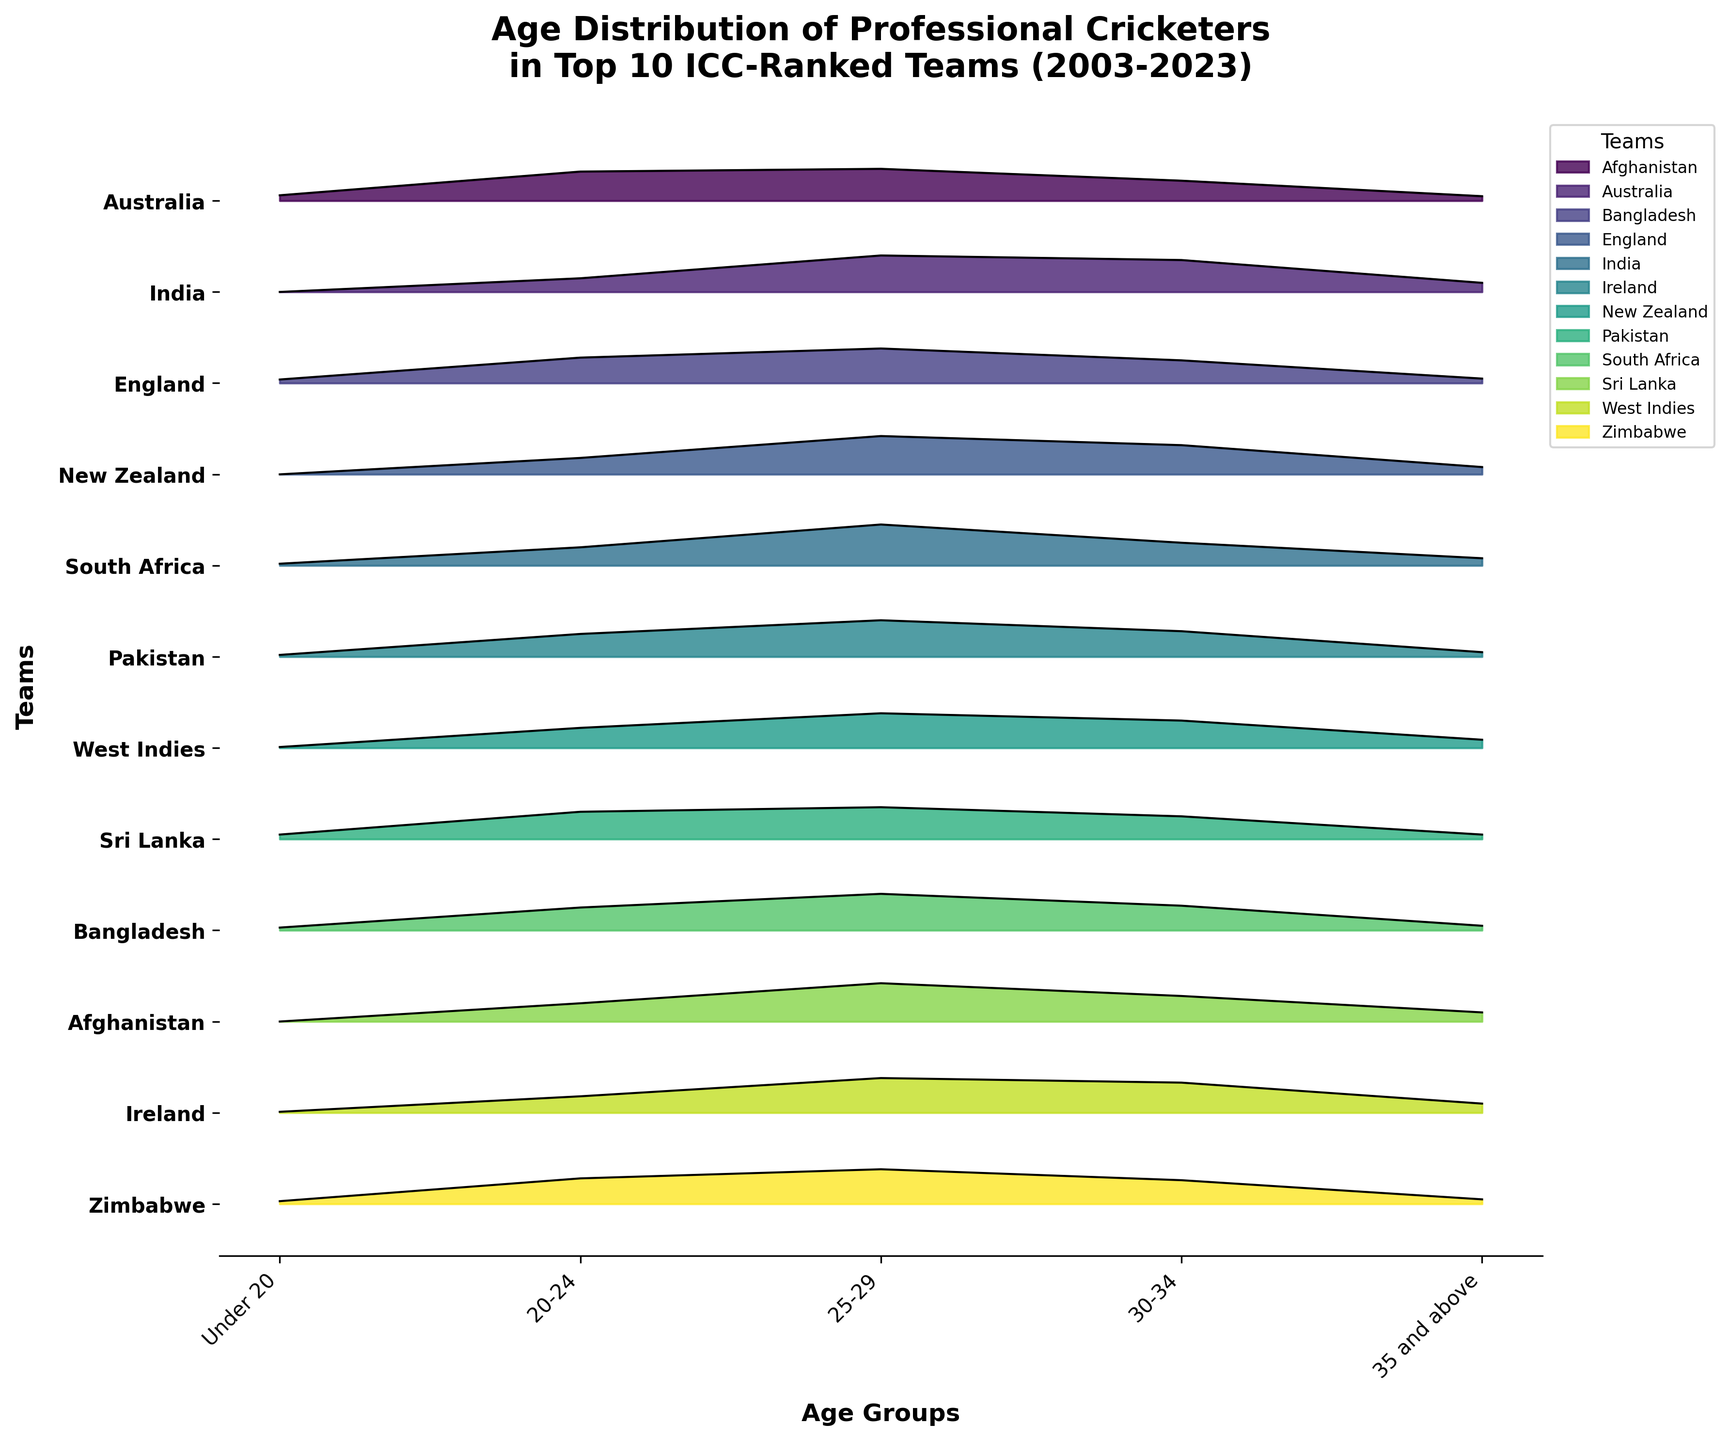Which team has the highest proportion of players aged under 20 in 2023? Look at the 'Under 20' age group for the year 2023 and compare the values for each team. The team with the highest proportion is Pakistan with 5.
Answer: Pakistan What is the title of the figure? The title is at the top of the figure. It states, 'Age Distribution of Professional Cricketers in Top 10 ICC-Ranked Teams (2003-2023)'.
Answer: Age Distribution of Professional Cricketers in Top 10 ICC-Ranked Teams (2003-2023) Between New Zealand in 2015 and South Africa in 2019, which team has a higher proportion of players aged 30-34? Compare the values for the '30-34' age group for New Zealand (2015) with South Africa (2019). New Zealand has 30% while South Africa has 27%.
Answer: New Zealand Which age group has the highest proportion of players in Bangladesh in 2011? Look at the values for each age group in Bangladesh for the year 2011. The highest value is found in the '20-24' category with 28%.
Answer: 20-24 How does the proportion of players aged 35 and above in Australia in 2003 compare to that in West Indies in the same year? Compare the '35 and above' group for both Australia and West Indies in 2003. Both teams have the same proportion, 10%.
Answer: Equal What range of years does the figure cover? Look at the axis labels or title of the figure to determine the range of years. The figure covers data from 2003 to 2023.
Answer: 2003-2023 Which team has the lowest proportion of players aged 20-24 in 2007? Compare the '20-24' values for each team in 2007. The lowest value is with Sri Lanka at 20%.
Answer: Sri Lanka What is the overall trend for players aged 35 and above from 2003 to 2023 based on the figure? Observe the proportion of the '35 and above' age group across all teams and years. The proportion remains relatively low and consistent around 5-10%.
Answer: Relatively low and consistent In which year and team is the highest proportion of players aged 25-29? Compare the values for '25-29' group across all years and teams. The highest value is found in India in 2007 with 45%.
Answer: India 2007 